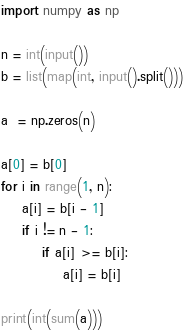<code> <loc_0><loc_0><loc_500><loc_500><_Python_>import numpy as np

n = int(input())
b = list(map(int, input().split()))

a  = np.zeros(n)

a[0] = b[0]
for i in range(1, n):
    a[i] = b[i - 1]
    if i != n - 1:
        if a[i] >= b[i]:
            a[i] = b[i]

print(int(sum(a)))</code> 